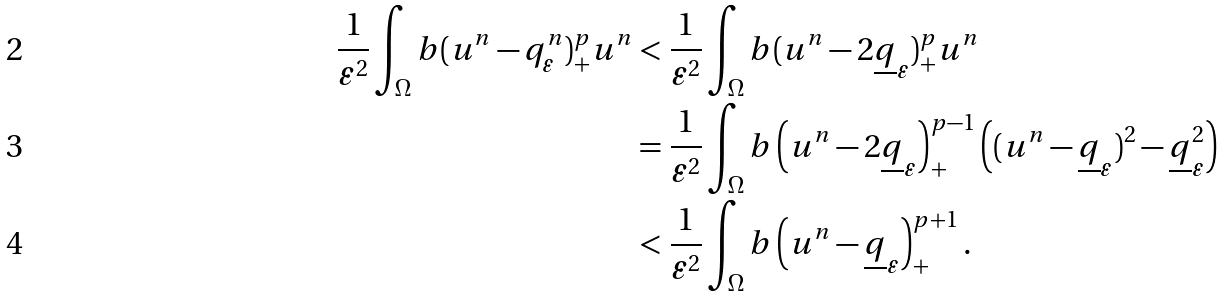<formula> <loc_0><loc_0><loc_500><loc_500>\frac { 1 } { \varepsilon ^ { 2 } } \int _ { \Omega } b ( u ^ { n } - q _ { \varepsilon } ^ { n } ) ^ { p } _ { + } u ^ { n } & < \frac { 1 } { \varepsilon ^ { 2 } } \int _ { \Omega } b ( u ^ { n } - 2 \underline { q } _ { \varepsilon } ) ^ { p } _ { + } u ^ { n } \\ & = \frac { 1 } { \varepsilon ^ { 2 } } \int _ { \Omega } b \left ( u ^ { n } - 2 \underline { q } _ { \varepsilon } \right ) ^ { p - 1 } _ { + } \left ( ( u ^ { n } - \underline { q } _ { \varepsilon } ) ^ { 2 } - \underline { q } _ { \varepsilon } ^ { 2 } \right ) \\ & < \frac { 1 } { \varepsilon ^ { 2 } } \int _ { \Omega } b \left ( u ^ { n } - \underline { q } _ { \varepsilon } \right ) ^ { p + 1 } _ { + } .</formula> 